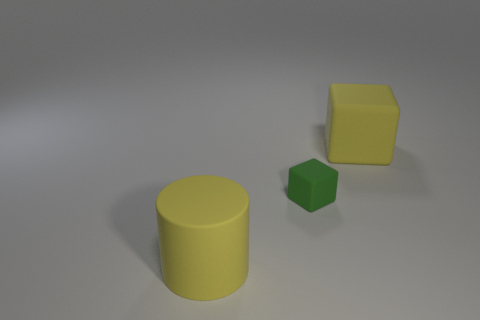Subtract all cyan cylinders. Subtract all cyan cubes. How many cylinders are left? 1 Add 2 yellow metallic things. How many objects exist? 5 Subtract all cubes. How many objects are left? 1 Subtract 1 yellow cubes. How many objects are left? 2 Subtract all big gray shiny blocks. Subtract all big yellow matte objects. How many objects are left? 1 Add 3 big yellow matte cubes. How many big yellow matte cubes are left? 4 Add 1 purple metal cylinders. How many purple metal cylinders exist? 1 